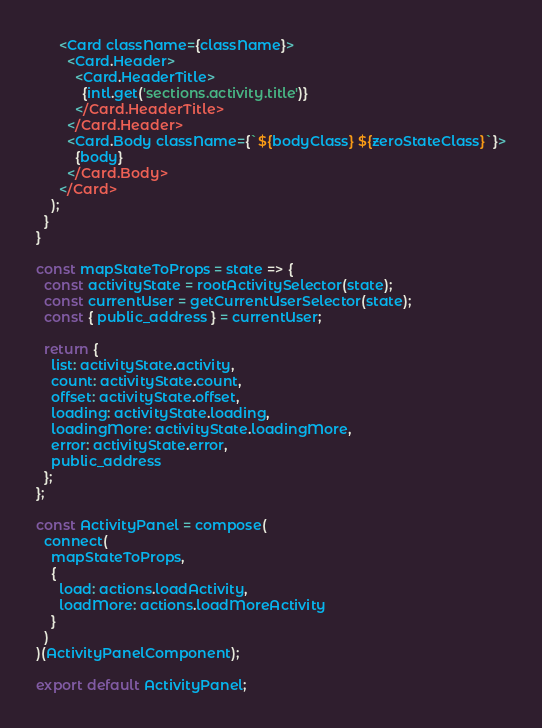<code> <loc_0><loc_0><loc_500><loc_500><_JavaScript_>      <Card className={className}>
        <Card.Header>
          <Card.HeaderTitle>
            {intl.get('sections.activity.title')}
          </Card.HeaderTitle>
        </Card.Header>
        <Card.Body className={`${bodyClass} ${zeroStateClass}`}>
          {body}
        </Card.Body>
      </Card>
    );
  }
}

const mapStateToProps = state => {
  const activityState = rootActivitySelector(state);
  const currentUser = getCurrentUserSelector(state);
  const { public_address } = currentUser;

  return {
    list: activityState.activity,
    count: activityState.count,
    offset: activityState.offset,
    loading: activityState.loading,
    loadingMore: activityState.loadingMore,
    error: activityState.error,
    public_address
  };
};

const ActivityPanel = compose(
  connect(
    mapStateToProps,
    {
      load: actions.loadActivity,
      loadMore: actions.loadMoreActivity
    }
  )
)(ActivityPanelComponent);

export default ActivityPanel;
</code> 